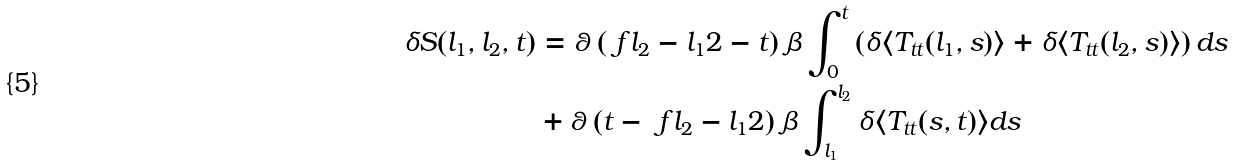<formula> <loc_0><loc_0><loc_500><loc_500>\delta S ( l _ { 1 } , l _ { 2 } , t ) & = \theta \left ( \ f { l _ { 2 } - l _ { 1 } } { 2 } - t \right ) \beta \int ^ { t } _ { 0 } \left ( \delta \langle T _ { t t } ( l _ { 1 } , s ) \rangle + \delta \langle T _ { t t } ( l _ { 2 } , s ) \rangle \right ) d s \\ & + \theta \left ( t - \ f { l _ { 2 } - l _ { 1 } } { 2 } \right ) \beta \int ^ { l _ { 2 } } _ { l _ { 1 } } \delta \langle T _ { t t } ( s , t ) \rangle d s</formula> 